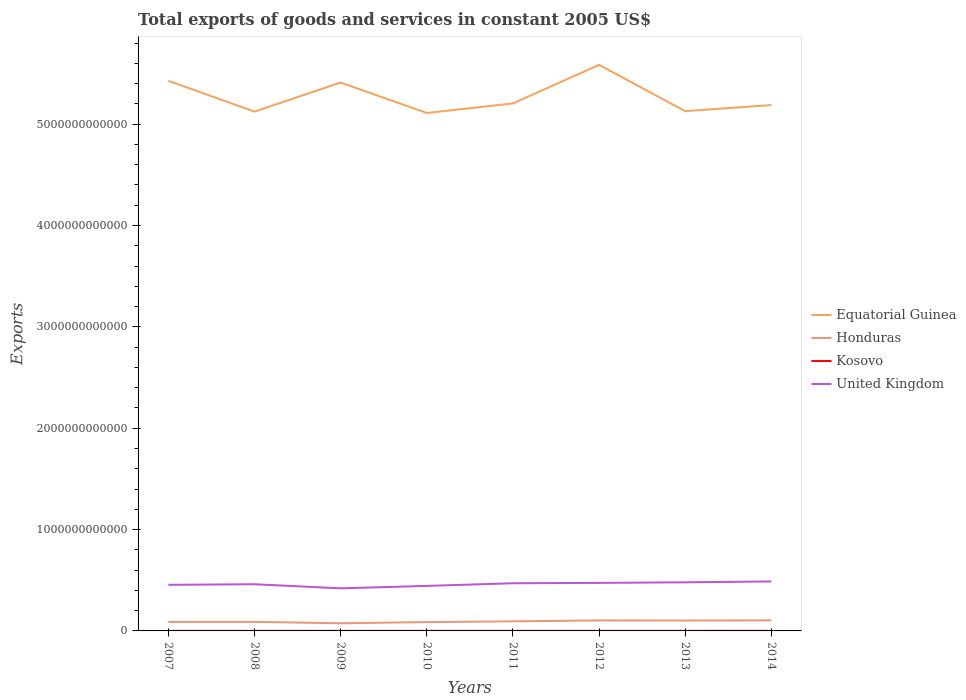Does the line corresponding to United Kingdom intersect with the line corresponding to Kosovo?
Your answer should be compact. No. Across all years, what is the maximum total exports of goods and services in United Kingdom?
Make the answer very short. 4.20e+11. What is the total total exports of goods and services in United Kingdom in the graph?
Provide a succinct answer. -5.37e+1. What is the difference between the highest and the second highest total exports of goods and services in Equatorial Guinea?
Your answer should be very brief. 4.75e+11. What is the difference between the highest and the lowest total exports of goods and services in Honduras?
Ensure brevity in your answer.  4. Is the total exports of goods and services in Kosovo strictly greater than the total exports of goods and services in Equatorial Guinea over the years?
Give a very brief answer. Yes. How many years are there in the graph?
Offer a terse response. 8. What is the difference between two consecutive major ticks on the Y-axis?
Your answer should be compact. 1.00e+12. Are the values on the major ticks of Y-axis written in scientific E-notation?
Keep it short and to the point. No. How many legend labels are there?
Your answer should be very brief. 4. How are the legend labels stacked?
Give a very brief answer. Vertical. What is the title of the graph?
Keep it short and to the point. Total exports of goods and services in constant 2005 US$. Does "Czech Republic" appear as one of the legend labels in the graph?
Give a very brief answer. No. What is the label or title of the Y-axis?
Your answer should be very brief. Exports. What is the Exports of Equatorial Guinea in 2007?
Give a very brief answer. 5.43e+12. What is the Exports in Honduras in 2007?
Make the answer very short. 8.89e+1. What is the Exports in Kosovo in 2007?
Offer a terse response. 6.08e+08. What is the Exports in United Kingdom in 2007?
Your answer should be compact. 4.55e+11. What is the Exports of Equatorial Guinea in 2008?
Your answer should be compact. 5.12e+12. What is the Exports of Honduras in 2008?
Offer a terse response. 8.96e+1. What is the Exports in Kosovo in 2008?
Your answer should be compact. 6.09e+08. What is the Exports in United Kingdom in 2008?
Give a very brief answer. 4.61e+11. What is the Exports in Equatorial Guinea in 2009?
Your response must be concise. 5.41e+12. What is the Exports in Honduras in 2009?
Keep it short and to the point. 7.54e+1. What is the Exports in Kosovo in 2009?
Your answer should be compact. 6.85e+08. What is the Exports of United Kingdom in 2009?
Your answer should be very brief. 4.20e+11. What is the Exports of Equatorial Guinea in 2010?
Make the answer very short. 5.11e+12. What is the Exports in Honduras in 2010?
Ensure brevity in your answer.  8.72e+1. What is the Exports of Kosovo in 2010?
Offer a very short reply. 7.70e+08. What is the Exports in United Kingdom in 2010?
Provide a short and direct response. 4.44e+11. What is the Exports in Equatorial Guinea in 2011?
Give a very brief answer. 5.20e+12. What is the Exports in Honduras in 2011?
Your answer should be compact. 9.45e+1. What is the Exports of Kosovo in 2011?
Your response must be concise. 8.00e+08. What is the Exports of United Kingdom in 2011?
Provide a succinct answer. 4.70e+11. What is the Exports in Equatorial Guinea in 2012?
Your answer should be very brief. 5.59e+12. What is the Exports of Honduras in 2012?
Give a very brief answer. 1.04e+11. What is the Exports in Kosovo in 2012?
Ensure brevity in your answer.  8.06e+08. What is the Exports in United Kingdom in 2012?
Offer a terse response. 4.74e+11. What is the Exports in Equatorial Guinea in 2013?
Your response must be concise. 5.13e+12. What is the Exports of Honduras in 2013?
Offer a very short reply. 1.02e+11. What is the Exports in Kosovo in 2013?
Provide a succinct answer. 8.24e+08. What is the Exports in United Kingdom in 2013?
Make the answer very short. 4.80e+11. What is the Exports of Equatorial Guinea in 2014?
Your answer should be compact. 5.19e+12. What is the Exports in Honduras in 2014?
Make the answer very short. 1.04e+11. What is the Exports in Kosovo in 2014?
Keep it short and to the point. 9.65e+08. What is the Exports in United Kingdom in 2014?
Your answer should be compact. 4.88e+11. Across all years, what is the maximum Exports of Equatorial Guinea?
Make the answer very short. 5.59e+12. Across all years, what is the maximum Exports in Honduras?
Your response must be concise. 1.04e+11. Across all years, what is the maximum Exports of Kosovo?
Offer a very short reply. 9.65e+08. Across all years, what is the maximum Exports in United Kingdom?
Your response must be concise. 4.88e+11. Across all years, what is the minimum Exports in Equatorial Guinea?
Ensure brevity in your answer.  5.11e+12. Across all years, what is the minimum Exports of Honduras?
Give a very brief answer. 7.54e+1. Across all years, what is the minimum Exports in Kosovo?
Your answer should be very brief. 6.08e+08. Across all years, what is the minimum Exports in United Kingdom?
Offer a very short reply. 4.20e+11. What is the total Exports of Equatorial Guinea in the graph?
Your answer should be very brief. 4.22e+13. What is the total Exports in Honduras in the graph?
Offer a very short reply. 7.46e+11. What is the total Exports of Kosovo in the graph?
Your answer should be very brief. 6.07e+09. What is the total Exports in United Kingdom in the graph?
Your answer should be compact. 3.69e+12. What is the difference between the Exports in Equatorial Guinea in 2007 and that in 2008?
Give a very brief answer. 3.04e+11. What is the difference between the Exports in Honduras in 2007 and that in 2008?
Provide a succinct answer. -7.64e+08. What is the difference between the Exports in Kosovo in 2007 and that in 2008?
Ensure brevity in your answer.  -5.00e+05. What is the difference between the Exports of United Kingdom in 2007 and that in 2008?
Provide a succinct answer. -5.89e+09. What is the difference between the Exports of Equatorial Guinea in 2007 and that in 2009?
Provide a succinct answer. 1.72e+1. What is the difference between the Exports of Honduras in 2007 and that in 2009?
Your answer should be compact. 1.35e+1. What is the difference between the Exports of Kosovo in 2007 and that in 2009?
Offer a very short reply. -7.64e+07. What is the difference between the Exports in United Kingdom in 2007 and that in 2009?
Your answer should be compact. 3.47e+1. What is the difference between the Exports in Equatorial Guinea in 2007 and that in 2010?
Offer a terse response. 3.18e+11. What is the difference between the Exports of Honduras in 2007 and that in 2010?
Your answer should be compact. 1.66e+09. What is the difference between the Exports in Kosovo in 2007 and that in 2010?
Offer a very short reply. -1.62e+08. What is the difference between the Exports of United Kingdom in 2007 and that in 2010?
Ensure brevity in your answer.  1.05e+1. What is the difference between the Exports in Equatorial Guinea in 2007 and that in 2011?
Provide a short and direct response. 2.23e+11. What is the difference between the Exports of Honduras in 2007 and that in 2011?
Your answer should be compact. -5.63e+09. What is the difference between the Exports of Kosovo in 2007 and that in 2011?
Ensure brevity in your answer.  -1.92e+08. What is the difference between the Exports in United Kingdom in 2007 and that in 2011?
Keep it short and to the point. -1.55e+1. What is the difference between the Exports of Equatorial Guinea in 2007 and that in 2012?
Keep it short and to the point. -1.57e+11. What is the difference between the Exports in Honduras in 2007 and that in 2012?
Your answer should be very brief. -1.49e+1. What is the difference between the Exports in Kosovo in 2007 and that in 2012?
Offer a terse response. -1.97e+08. What is the difference between the Exports in United Kingdom in 2007 and that in 2012?
Ensure brevity in your answer.  -1.90e+1. What is the difference between the Exports in Equatorial Guinea in 2007 and that in 2013?
Your answer should be compact. 2.99e+11. What is the difference between the Exports in Honduras in 2007 and that in 2013?
Provide a succinct answer. -1.36e+1. What is the difference between the Exports of Kosovo in 2007 and that in 2013?
Your answer should be very brief. -2.16e+08. What is the difference between the Exports of United Kingdom in 2007 and that in 2013?
Keep it short and to the point. -2.48e+1. What is the difference between the Exports in Equatorial Guinea in 2007 and that in 2014?
Give a very brief answer. 2.39e+11. What is the difference between the Exports in Honduras in 2007 and that in 2014?
Offer a very short reply. -1.52e+1. What is the difference between the Exports of Kosovo in 2007 and that in 2014?
Offer a very short reply. -3.57e+08. What is the difference between the Exports in United Kingdom in 2007 and that in 2014?
Offer a very short reply. -3.35e+1. What is the difference between the Exports in Equatorial Guinea in 2008 and that in 2009?
Offer a very short reply. -2.87e+11. What is the difference between the Exports of Honduras in 2008 and that in 2009?
Your answer should be compact. 1.42e+1. What is the difference between the Exports of Kosovo in 2008 and that in 2009?
Offer a very short reply. -7.59e+07. What is the difference between the Exports of United Kingdom in 2008 and that in 2009?
Ensure brevity in your answer.  4.05e+1. What is the difference between the Exports in Equatorial Guinea in 2008 and that in 2010?
Your answer should be compact. 1.39e+1. What is the difference between the Exports in Honduras in 2008 and that in 2010?
Provide a short and direct response. 2.42e+09. What is the difference between the Exports in Kosovo in 2008 and that in 2010?
Keep it short and to the point. -1.62e+08. What is the difference between the Exports in United Kingdom in 2008 and that in 2010?
Your answer should be compact. 1.63e+1. What is the difference between the Exports of Equatorial Guinea in 2008 and that in 2011?
Keep it short and to the point. -8.05e+1. What is the difference between the Exports in Honduras in 2008 and that in 2011?
Your answer should be compact. -4.87e+09. What is the difference between the Exports of Kosovo in 2008 and that in 2011?
Ensure brevity in your answer.  -1.91e+08. What is the difference between the Exports in United Kingdom in 2008 and that in 2011?
Your answer should be compact. -9.64e+09. What is the difference between the Exports in Equatorial Guinea in 2008 and that in 2012?
Ensure brevity in your answer.  -4.61e+11. What is the difference between the Exports of Honduras in 2008 and that in 2012?
Provide a succinct answer. -1.42e+1. What is the difference between the Exports of Kosovo in 2008 and that in 2012?
Give a very brief answer. -1.97e+08. What is the difference between the Exports of United Kingdom in 2008 and that in 2012?
Make the answer very short. -1.32e+1. What is the difference between the Exports of Equatorial Guinea in 2008 and that in 2013?
Ensure brevity in your answer.  -4.32e+09. What is the difference between the Exports in Honduras in 2008 and that in 2013?
Provide a succinct answer. -1.28e+1. What is the difference between the Exports in Kosovo in 2008 and that in 2013?
Provide a short and direct response. -2.15e+08. What is the difference between the Exports in United Kingdom in 2008 and that in 2013?
Your answer should be compact. -1.89e+1. What is the difference between the Exports of Equatorial Guinea in 2008 and that in 2014?
Offer a terse response. -6.45e+1. What is the difference between the Exports of Honduras in 2008 and that in 2014?
Keep it short and to the point. -1.45e+1. What is the difference between the Exports in Kosovo in 2008 and that in 2014?
Give a very brief answer. -3.56e+08. What is the difference between the Exports in United Kingdom in 2008 and that in 2014?
Your answer should be compact. -2.76e+1. What is the difference between the Exports in Equatorial Guinea in 2009 and that in 2010?
Your response must be concise. 3.01e+11. What is the difference between the Exports in Honduras in 2009 and that in 2010?
Make the answer very short. -1.18e+1. What is the difference between the Exports of Kosovo in 2009 and that in 2010?
Offer a terse response. -8.56e+07. What is the difference between the Exports of United Kingdom in 2009 and that in 2010?
Your answer should be compact. -2.42e+1. What is the difference between the Exports in Equatorial Guinea in 2009 and that in 2011?
Provide a succinct answer. 2.06e+11. What is the difference between the Exports of Honduras in 2009 and that in 2011?
Keep it short and to the point. -1.91e+1. What is the difference between the Exports of Kosovo in 2009 and that in 2011?
Offer a terse response. -1.15e+08. What is the difference between the Exports in United Kingdom in 2009 and that in 2011?
Make the answer very short. -5.02e+1. What is the difference between the Exports in Equatorial Guinea in 2009 and that in 2012?
Give a very brief answer. -1.74e+11. What is the difference between the Exports in Honduras in 2009 and that in 2012?
Keep it short and to the point. -2.84e+1. What is the difference between the Exports in Kosovo in 2009 and that in 2012?
Your answer should be compact. -1.21e+08. What is the difference between the Exports in United Kingdom in 2009 and that in 2012?
Your answer should be very brief. -5.37e+1. What is the difference between the Exports of Equatorial Guinea in 2009 and that in 2013?
Keep it short and to the point. 2.82e+11. What is the difference between the Exports in Honduras in 2009 and that in 2013?
Give a very brief answer. -2.71e+1. What is the difference between the Exports of Kosovo in 2009 and that in 2013?
Give a very brief answer. -1.39e+08. What is the difference between the Exports in United Kingdom in 2009 and that in 2013?
Give a very brief answer. -5.94e+1. What is the difference between the Exports in Equatorial Guinea in 2009 and that in 2014?
Keep it short and to the point. 2.22e+11. What is the difference between the Exports of Honduras in 2009 and that in 2014?
Ensure brevity in your answer.  -2.87e+1. What is the difference between the Exports of Kosovo in 2009 and that in 2014?
Your response must be concise. -2.80e+08. What is the difference between the Exports of United Kingdom in 2009 and that in 2014?
Provide a succinct answer. -6.81e+1. What is the difference between the Exports of Equatorial Guinea in 2010 and that in 2011?
Offer a terse response. -9.44e+1. What is the difference between the Exports in Honduras in 2010 and that in 2011?
Your answer should be compact. -7.29e+09. What is the difference between the Exports of Kosovo in 2010 and that in 2011?
Provide a succinct answer. -2.96e+07. What is the difference between the Exports in United Kingdom in 2010 and that in 2011?
Keep it short and to the point. -2.60e+1. What is the difference between the Exports in Equatorial Guinea in 2010 and that in 2012?
Provide a short and direct response. -4.75e+11. What is the difference between the Exports of Honduras in 2010 and that in 2012?
Provide a succinct answer. -1.66e+1. What is the difference between the Exports in Kosovo in 2010 and that in 2012?
Ensure brevity in your answer.  -3.52e+07. What is the difference between the Exports in United Kingdom in 2010 and that in 2012?
Give a very brief answer. -2.95e+1. What is the difference between the Exports in Equatorial Guinea in 2010 and that in 2013?
Provide a short and direct response. -1.83e+1. What is the difference between the Exports of Honduras in 2010 and that in 2013?
Provide a succinct answer. -1.53e+1. What is the difference between the Exports in Kosovo in 2010 and that in 2013?
Make the answer very short. -5.38e+07. What is the difference between the Exports in United Kingdom in 2010 and that in 2013?
Keep it short and to the point. -3.52e+1. What is the difference between the Exports of Equatorial Guinea in 2010 and that in 2014?
Your answer should be very brief. -7.84e+1. What is the difference between the Exports of Honduras in 2010 and that in 2014?
Provide a succinct answer. -1.69e+1. What is the difference between the Exports in Kosovo in 2010 and that in 2014?
Provide a succinct answer. -1.95e+08. What is the difference between the Exports of United Kingdom in 2010 and that in 2014?
Keep it short and to the point. -4.39e+1. What is the difference between the Exports of Equatorial Guinea in 2011 and that in 2012?
Make the answer very short. -3.80e+11. What is the difference between the Exports in Honduras in 2011 and that in 2012?
Give a very brief answer. -9.31e+09. What is the difference between the Exports of Kosovo in 2011 and that in 2012?
Give a very brief answer. -5.60e+06. What is the difference between the Exports in United Kingdom in 2011 and that in 2012?
Offer a terse response. -3.51e+09. What is the difference between the Exports in Equatorial Guinea in 2011 and that in 2013?
Offer a very short reply. 7.62e+1. What is the difference between the Exports in Honduras in 2011 and that in 2013?
Offer a very short reply. -7.98e+09. What is the difference between the Exports of Kosovo in 2011 and that in 2013?
Offer a terse response. -2.42e+07. What is the difference between the Exports in United Kingdom in 2011 and that in 2013?
Offer a terse response. -9.24e+09. What is the difference between the Exports in Equatorial Guinea in 2011 and that in 2014?
Offer a terse response. 1.60e+1. What is the difference between the Exports of Honduras in 2011 and that in 2014?
Keep it short and to the point. -9.58e+09. What is the difference between the Exports in Kosovo in 2011 and that in 2014?
Keep it short and to the point. -1.65e+08. What is the difference between the Exports in United Kingdom in 2011 and that in 2014?
Provide a short and direct response. -1.79e+1. What is the difference between the Exports in Equatorial Guinea in 2012 and that in 2013?
Your response must be concise. 4.57e+11. What is the difference between the Exports of Honduras in 2012 and that in 2013?
Give a very brief answer. 1.33e+09. What is the difference between the Exports in Kosovo in 2012 and that in 2013?
Keep it short and to the point. -1.86e+07. What is the difference between the Exports of United Kingdom in 2012 and that in 2013?
Your answer should be compact. -5.73e+09. What is the difference between the Exports of Equatorial Guinea in 2012 and that in 2014?
Provide a short and direct response. 3.96e+11. What is the difference between the Exports of Honduras in 2012 and that in 2014?
Keep it short and to the point. -2.79e+08. What is the difference between the Exports of Kosovo in 2012 and that in 2014?
Ensure brevity in your answer.  -1.59e+08. What is the difference between the Exports of United Kingdom in 2012 and that in 2014?
Ensure brevity in your answer.  -1.44e+1. What is the difference between the Exports in Equatorial Guinea in 2013 and that in 2014?
Your response must be concise. -6.02e+1. What is the difference between the Exports in Honduras in 2013 and that in 2014?
Keep it short and to the point. -1.61e+09. What is the difference between the Exports of Kosovo in 2013 and that in 2014?
Provide a succinct answer. -1.41e+08. What is the difference between the Exports in United Kingdom in 2013 and that in 2014?
Offer a terse response. -8.71e+09. What is the difference between the Exports of Equatorial Guinea in 2007 and the Exports of Honduras in 2008?
Offer a very short reply. 5.34e+12. What is the difference between the Exports in Equatorial Guinea in 2007 and the Exports in Kosovo in 2008?
Keep it short and to the point. 5.43e+12. What is the difference between the Exports of Equatorial Guinea in 2007 and the Exports of United Kingdom in 2008?
Offer a very short reply. 4.97e+12. What is the difference between the Exports of Honduras in 2007 and the Exports of Kosovo in 2008?
Your answer should be very brief. 8.82e+1. What is the difference between the Exports of Honduras in 2007 and the Exports of United Kingdom in 2008?
Ensure brevity in your answer.  -3.72e+11. What is the difference between the Exports of Kosovo in 2007 and the Exports of United Kingdom in 2008?
Give a very brief answer. -4.60e+11. What is the difference between the Exports in Equatorial Guinea in 2007 and the Exports in Honduras in 2009?
Your response must be concise. 5.35e+12. What is the difference between the Exports of Equatorial Guinea in 2007 and the Exports of Kosovo in 2009?
Your response must be concise. 5.43e+12. What is the difference between the Exports in Equatorial Guinea in 2007 and the Exports in United Kingdom in 2009?
Your answer should be compact. 5.01e+12. What is the difference between the Exports of Honduras in 2007 and the Exports of Kosovo in 2009?
Your answer should be compact. 8.82e+1. What is the difference between the Exports of Honduras in 2007 and the Exports of United Kingdom in 2009?
Offer a terse response. -3.31e+11. What is the difference between the Exports in Kosovo in 2007 and the Exports in United Kingdom in 2009?
Your response must be concise. -4.20e+11. What is the difference between the Exports in Equatorial Guinea in 2007 and the Exports in Honduras in 2010?
Give a very brief answer. 5.34e+12. What is the difference between the Exports in Equatorial Guinea in 2007 and the Exports in Kosovo in 2010?
Give a very brief answer. 5.43e+12. What is the difference between the Exports in Equatorial Guinea in 2007 and the Exports in United Kingdom in 2010?
Keep it short and to the point. 4.98e+12. What is the difference between the Exports in Honduras in 2007 and the Exports in Kosovo in 2010?
Your answer should be very brief. 8.81e+1. What is the difference between the Exports in Honduras in 2007 and the Exports in United Kingdom in 2010?
Ensure brevity in your answer.  -3.56e+11. What is the difference between the Exports of Kosovo in 2007 and the Exports of United Kingdom in 2010?
Ensure brevity in your answer.  -4.44e+11. What is the difference between the Exports of Equatorial Guinea in 2007 and the Exports of Honduras in 2011?
Give a very brief answer. 5.33e+12. What is the difference between the Exports of Equatorial Guinea in 2007 and the Exports of Kosovo in 2011?
Ensure brevity in your answer.  5.43e+12. What is the difference between the Exports in Equatorial Guinea in 2007 and the Exports in United Kingdom in 2011?
Your response must be concise. 4.96e+12. What is the difference between the Exports of Honduras in 2007 and the Exports of Kosovo in 2011?
Your response must be concise. 8.81e+1. What is the difference between the Exports of Honduras in 2007 and the Exports of United Kingdom in 2011?
Your answer should be compact. -3.81e+11. What is the difference between the Exports in Kosovo in 2007 and the Exports in United Kingdom in 2011?
Your answer should be very brief. -4.70e+11. What is the difference between the Exports in Equatorial Guinea in 2007 and the Exports in Honduras in 2012?
Provide a succinct answer. 5.32e+12. What is the difference between the Exports of Equatorial Guinea in 2007 and the Exports of Kosovo in 2012?
Offer a very short reply. 5.43e+12. What is the difference between the Exports of Equatorial Guinea in 2007 and the Exports of United Kingdom in 2012?
Your answer should be very brief. 4.95e+12. What is the difference between the Exports of Honduras in 2007 and the Exports of Kosovo in 2012?
Ensure brevity in your answer.  8.80e+1. What is the difference between the Exports of Honduras in 2007 and the Exports of United Kingdom in 2012?
Provide a short and direct response. -3.85e+11. What is the difference between the Exports of Kosovo in 2007 and the Exports of United Kingdom in 2012?
Provide a short and direct response. -4.73e+11. What is the difference between the Exports of Equatorial Guinea in 2007 and the Exports of Honduras in 2013?
Your answer should be compact. 5.33e+12. What is the difference between the Exports in Equatorial Guinea in 2007 and the Exports in Kosovo in 2013?
Your response must be concise. 5.43e+12. What is the difference between the Exports in Equatorial Guinea in 2007 and the Exports in United Kingdom in 2013?
Offer a terse response. 4.95e+12. What is the difference between the Exports of Honduras in 2007 and the Exports of Kosovo in 2013?
Your answer should be very brief. 8.80e+1. What is the difference between the Exports in Honduras in 2007 and the Exports in United Kingdom in 2013?
Ensure brevity in your answer.  -3.91e+11. What is the difference between the Exports of Kosovo in 2007 and the Exports of United Kingdom in 2013?
Keep it short and to the point. -4.79e+11. What is the difference between the Exports in Equatorial Guinea in 2007 and the Exports in Honduras in 2014?
Your response must be concise. 5.32e+12. What is the difference between the Exports in Equatorial Guinea in 2007 and the Exports in Kosovo in 2014?
Provide a short and direct response. 5.43e+12. What is the difference between the Exports in Equatorial Guinea in 2007 and the Exports in United Kingdom in 2014?
Give a very brief answer. 4.94e+12. What is the difference between the Exports of Honduras in 2007 and the Exports of Kosovo in 2014?
Provide a succinct answer. 8.79e+1. What is the difference between the Exports of Honduras in 2007 and the Exports of United Kingdom in 2014?
Provide a succinct answer. -3.99e+11. What is the difference between the Exports in Kosovo in 2007 and the Exports in United Kingdom in 2014?
Offer a very short reply. -4.88e+11. What is the difference between the Exports in Equatorial Guinea in 2008 and the Exports in Honduras in 2009?
Make the answer very short. 5.05e+12. What is the difference between the Exports of Equatorial Guinea in 2008 and the Exports of Kosovo in 2009?
Provide a succinct answer. 5.12e+12. What is the difference between the Exports of Equatorial Guinea in 2008 and the Exports of United Kingdom in 2009?
Make the answer very short. 4.70e+12. What is the difference between the Exports in Honduras in 2008 and the Exports in Kosovo in 2009?
Offer a very short reply. 8.89e+1. What is the difference between the Exports of Honduras in 2008 and the Exports of United Kingdom in 2009?
Offer a very short reply. -3.31e+11. What is the difference between the Exports in Kosovo in 2008 and the Exports in United Kingdom in 2009?
Make the answer very short. -4.20e+11. What is the difference between the Exports in Equatorial Guinea in 2008 and the Exports in Honduras in 2010?
Your response must be concise. 5.04e+12. What is the difference between the Exports of Equatorial Guinea in 2008 and the Exports of Kosovo in 2010?
Make the answer very short. 5.12e+12. What is the difference between the Exports of Equatorial Guinea in 2008 and the Exports of United Kingdom in 2010?
Make the answer very short. 4.68e+12. What is the difference between the Exports of Honduras in 2008 and the Exports of Kosovo in 2010?
Offer a terse response. 8.88e+1. What is the difference between the Exports of Honduras in 2008 and the Exports of United Kingdom in 2010?
Your response must be concise. -3.55e+11. What is the difference between the Exports of Kosovo in 2008 and the Exports of United Kingdom in 2010?
Offer a terse response. -4.44e+11. What is the difference between the Exports in Equatorial Guinea in 2008 and the Exports in Honduras in 2011?
Ensure brevity in your answer.  5.03e+12. What is the difference between the Exports in Equatorial Guinea in 2008 and the Exports in Kosovo in 2011?
Provide a succinct answer. 5.12e+12. What is the difference between the Exports in Equatorial Guinea in 2008 and the Exports in United Kingdom in 2011?
Your answer should be compact. 4.65e+12. What is the difference between the Exports of Honduras in 2008 and the Exports of Kosovo in 2011?
Provide a short and direct response. 8.88e+1. What is the difference between the Exports of Honduras in 2008 and the Exports of United Kingdom in 2011?
Offer a very short reply. -3.81e+11. What is the difference between the Exports in Kosovo in 2008 and the Exports in United Kingdom in 2011?
Keep it short and to the point. -4.70e+11. What is the difference between the Exports of Equatorial Guinea in 2008 and the Exports of Honduras in 2012?
Offer a terse response. 5.02e+12. What is the difference between the Exports in Equatorial Guinea in 2008 and the Exports in Kosovo in 2012?
Keep it short and to the point. 5.12e+12. What is the difference between the Exports of Equatorial Guinea in 2008 and the Exports of United Kingdom in 2012?
Your answer should be compact. 4.65e+12. What is the difference between the Exports in Honduras in 2008 and the Exports in Kosovo in 2012?
Ensure brevity in your answer.  8.88e+1. What is the difference between the Exports of Honduras in 2008 and the Exports of United Kingdom in 2012?
Provide a succinct answer. -3.84e+11. What is the difference between the Exports in Kosovo in 2008 and the Exports in United Kingdom in 2012?
Your response must be concise. -4.73e+11. What is the difference between the Exports of Equatorial Guinea in 2008 and the Exports of Honduras in 2013?
Ensure brevity in your answer.  5.02e+12. What is the difference between the Exports in Equatorial Guinea in 2008 and the Exports in Kosovo in 2013?
Your response must be concise. 5.12e+12. What is the difference between the Exports in Equatorial Guinea in 2008 and the Exports in United Kingdom in 2013?
Ensure brevity in your answer.  4.64e+12. What is the difference between the Exports of Honduras in 2008 and the Exports of Kosovo in 2013?
Your response must be concise. 8.88e+1. What is the difference between the Exports of Honduras in 2008 and the Exports of United Kingdom in 2013?
Your answer should be very brief. -3.90e+11. What is the difference between the Exports in Kosovo in 2008 and the Exports in United Kingdom in 2013?
Give a very brief answer. -4.79e+11. What is the difference between the Exports in Equatorial Guinea in 2008 and the Exports in Honduras in 2014?
Your answer should be compact. 5.02e+12. What is the difference between the Exports of Equatorial Guinea in 2008 and the Exports of Kosovo in 2014?
Offer a terse response. 5.12e+12. What is the difference between the Exports in Equatorial Guinea in 2008 and the Exports in United Kingdom in 2014?
Offer a very short reply. 4.64e+12. What is the difference between the Exports in Honduras in 2008 and the Exports in Kosovo in 2014?
Your answer should be very brief. 8.87e+1. What is the difference between the Exports in Honduras in 2008 and the Exports in United Kingdom in 2014?
Keep it short and to the point. -3.99e+11. What is the difference between the Exports in Kosovo in 2008 and the Exports in United Kingdom in 2014?
Provide a short and direct response. -4.88e+11. What is the difference between the Exports in Equatorial Guinea in 2009 and the Exports in Honduras in 2010?
Your answer should be very brief. 5.32e+12. What is the difference between the Exports in Equatorial Guinea in 2009 and the Exports in Kosovo in 2010?
Keep it short and to the point. 5.41e+12. What is the difference between the Exports in Equatorial Guinea in 2009 and the Exports in United Kingdom in 2010?
Give a very brief answer. 4.97e+12. What is the difference between the Exports in Honduras in 2009 and the Exports in Kosovo in 2010?
Provide a succinct answer. 7.46e+1. What is the difference between the Exports of Honduras in 2009 and the Exports of United Kingdom in 2010?
Provide a succinct answer. -3.69e+11. What is the difference between the Exports of Kosovo in 2009 and the Exports of United Kingdom in 2010?
Keep it short and to the point. -4.44e+11. What is the difference between the Exports of Equatorial Guinea in 2009 and the Exports of Honduras in 2011?
Provide a succinct answer. 5.32e+12. What is the difference between the Exports of Equatorial Guinea in 2009 and the Exports of Kosovo in 2011?
Offer a terse response. 5.41e+12. What is the difference between the Exports of Equatorial Guinea in 2009 and the Exports of United Kingdom in 2011?
Your answer should be compact. 4.94e+12. What is the difference between the Exports in Honduras in 2009 and the Exports in Kosovo in 2011?
Give a very brief answer. 7.46e+1. What is the difference between the Exports in Honduras in 2009 and the Exports in United Kingdom in 2011?
Offer a terse response. -3.95e+11. What is the difference between the Exports in Kosovo in 2009 and the Exports in United Kingdom in 2011?
Make the answer very short. -4.70e+11. What is the difference between the Exports in Equatorial Guinea in 2009 and the Exports in Honduras in 2012?
Give a very brief answer. 5.31e+12. What is the difference between the Exports in Equatorial Guinea in 2009 and the Exports in Kosovo in 2012?
Ensure brevity in your answer.  5.41e+12. What is the difference between the Exports in Equatorial Guinea in 2009 and the Exports in United Kingdom in 2012?
Keep it short and to the point. 4.94e+12. What is the difference between the Exports of Honduras in 2009 and the Exports of Kosovo in 2012?
Your answer should be compact. 7.46e+1. What is the difference between the Exports in Honduras in 2009 and the Exports in United Kingdom in 2012?
Offer a terse response. -3.98e+11. What is the difference between the Exports in Kosovo in 2009 and the Exports in United Kingdom in 2012?
Give a very brief answer. -4.73e+11. What is the difference between the Exports of Equatorial Guinea in 2009 and the Exports of Honduras in 2013?
Make the answer very short. 5.31e+12. What is the difference between the Exports in Equatorial Guinea in 2009 and the Exports in Kosovo in 2013?
Offer a very short reply. 5.41e+12. What is the difference between the Exports of Equatorial Guinea in 2009 and the Exports of United Kingdom in 2013?
Provide a short and direct response. 4.93e+12. What is the difference between the Exports in Honduras in 2009 and the Exports in Kosovo in 2013?
Offer a terse response. 7.45e+1. What is the difference between the Exports in Honduras in 2009 and the Exports in United Kingdom in 2013?
Provide a succinct answer. -4.04e+11. What is the difference between the Exports in Kosovo in 2009 and the Exports in United Kingdom in 2013?
Provide a succinct answer. -4.79e+11. What is the difference between the Exports in Equatorial Guinea in 2009 and the Exports in Honduras in 2014?
Your answer should be compact. 5.31e+12. What is the difference between the Exports in Equatorial Guinea in 2009 and the Exports in Kosovo in 2014?
Offer a terse response. 5.41e+12. What is the difference between the Exports in Equatorial Guinea in 2009 and the Exports in United Kingdom in 2014?
Your response must be concise. 4.92e+12. What is the difference between the Exports of Honduras in 2009 and the Exports of Kosovo in 2014?
Offer a very short reply. 7.44e+1. What is the difference between the Exports in Honduras in 2009 and the Exports in United Kingdom in 2014?
Provide a succinct answer. -4.13e+11. What is the difference between the Exports in Kosovo in 2009 and the Exports in United Kingdom in 2014?
Ensure brevity in your answer.  -4.88e+11. What is the difference between the Exports in Equatorial Guinea in 2010 and the Exports in Honduras in 2011?
Your answer should be very brief. 5.02e+12. What is the difference between the Exports in Equatorial Guinea in 2010 and the Exports in Kosovo in 2011?
Provide a short and direct response. 5.11e+12. What is the difference between the Exports in Equatorial Guinea in 2010 and the Exports in United Kingdom in 2011?
Your response must be concise. 4.64e+12. What is the difference between the Exports of Honduras in 2010 and the Exports of Kosovo in 2011?
Provide a short and direct response. 8.64e+1. What is the difference between the Exports of Honduras in 2010 and the Exports of United Kingdom in 2011?
Offer a terse response. -3.83e+11. What is the difference between the Exports of Kosovo in 2010 and the Exports of United Kingdom in 2011?
Provide a succinct answer. -4.70e+11. What is the difference between the Exports of Equatorial Guinea in 2010 and the Exports of Honduras in 2012?
Keep it short and to the point. 5.01e+12. What is the difference between the Exports in Equatorial Guinea in 2010 and the Exports in Kosovo in 2012?
Your answer should be very brief. 5.11e+12. What is the difference between the Exports of Equatorial Guinea in 2010 and the Exports of United Kingdom in 2012?
Provide a short and direct response. 4.64e+12. What is the difference between the Exports in Honduras in 2010 and the Exports in Kosovo in 2012?
Your response must be concise. 8.64e+1. What is the difference between the Exports of Honduras in 2010 and the Exports of United Kingdom in 2012?
Offer a terse response. -3.87e+11. What is the difference between the Exports of Kosovo in 2010 and the Exports of United Kingdom in 2012?
Offer a terse response. -4.73e+11. What is the difference between the Exports of Equatorial Guinea in 2010 and the Exports of Honduras in 2013?
Your answer should be compact. 5.01e+12. What is the difference between the Exports of Equatorial Guinea in 2010 and the Exports of Kosovo in 2013?
Give a very brief answer. 5.11e+12. What is the difference between the Exports in Equatorial Guinea in 2010 and the Exports in United Kingdom in 2013?
Give a very brief answer. 4.63e+12. What is the difference between the Exports of Honduras in 2010 and the Exports of Kosovo in 2013?
Provide a succinct answer. 8.64e+1. What is the difference between the Exports in Honduras in 2010 and the Exports in United Kingdom in 2013?
Your answer should be compact. -3.92e+11. What is the difference between the Exports of Kosovo in 2010 and the Exports of United Kingdom in 2013?
Your answer should be very brief. -4.79e+11. What is the difference between the Exports of Equatorial Guinea in 2010 and the Exports of Honduras in 2014?
Your answer should be compact. 5.01e+12. What is the difference between the Exports in Equatorial Guinea in 2010 and the Exports in Kosovo in 2014?
Keep it short and to the point. 5.11e+12. What is the difference between the Exports of Equatorial Guinea in 2010 and the Exports of United Kingdom in 2014?
Keep it short and to the point. 4.62e+12. What is the difference between the Exports of Honduras in 2010 and the Exports of Kosovo in 2014?
Offer a terse response. 8.62e+1. What is the difference between the Exports of Honduras in 2010 and the Exports of United Kingdom in 2014?
Make the answer very short. -4.01e+11. What is the difference between the Exports in Kosovo in 2010 and the Exports in United Kingdom in 2014?
Your answer should be very brief. -4.88e+11. What is the difference between the Exports in Equatorial Guinea in 2011 and the Exports in Honduras in 2012?
Provide a succinct answer. 5.10e+12. What is the difference between the Exports in Equatorial Guinea in 2011 and the Exports in Kosovo in 2012?
Offer a terse response. 5.20e+12. What is the difference between the Exports in Equatorial Guinea in 2011 and the Exports in United Kingdom in 2012?
Your answer should be compact. 4.73e+12. What is the difference between the Exports of Honduras in 2011 and the Exports of Kosovo in 2012?
Ensure brevity in your answer.  9.37e+1. What is the difference between the Exports of Honduras in 2011 and the Exports of United Kingdom in 2012?
Provide a succinct answer. -3.79e+11. What is the difference between the Exports in Kosovo in 2011 and the Exports in United Kingdom in 2012?
Make the answer very short. -4.73e+11. What is the difference between the Exports of Equatorial Guinea in 2011 and the Exports of Honduras in 2013?
Give a very brief answer. 5.10e+12. What is the difference between the Exports in Equatorial Guinea in 2011 and the Exports in Kosovo in 2013?
Give a very brief answer. 5.20e+12. What is the difference between the Exports of Equatorial Guinea in 2011 and the Exports of United Kingdom in 2013?
Give a very brief answer. 4.72e+12. What is the difference between the Exports in Honduras in 2011 and the Exports in Kosovo in 2013?
Your response must be concise. 9.37e+1. What is the difference between the Exports in Honduras in 2011 and the Exports in United Kingdom in 2013?
Provide a succinct answer. -3.85e+11. What is the difference between the Exports of Kosovo in 2011 and the Exports of United Kingdom in 2013?
Your answer should be compact. -4.79e+11. What is the difference between the Exports of Equatorial Guinea in 2011 and the Exports of Honduras in 2014?
Ensure brevity in your answer.  5.10e+12. What is the difference between the Exports of Equatorial Guinea in 2011 and the Exports of Kosovo in 2014?
Give a very brief answer. 5.20e+12. What is the difference between the Exports in Equatorial Guinea in 2011 and the Exports in United Kingdom in 2014?
Offer a terse response. 4.72e+12. What is the difference between the Exports in Honduras in 2011 and the Exports in Kosovo in 2014?
Ensure brevity in your answer.  9.35e+1. What is the difference between the Exports of Honduras in 2011 and the Exports of United Kingdom in 2014?
Your answer should be very brief. -3.94e+11. What is the difference between the Exports in Kosovo in 2011 and the Exports in United Kingdom in 2014?
Give a very brief answer. -4.87e+11. What is the difference between the Exports of Equatorial Guinea in 2012 and the Exports of Honduras in 2013?
Your answer should be very brief. 5.48e+12. What is the difference between the Exports of Equatorial Guinea in 2012 and the Exports of Kosovo in 2013?
Provide a succinct answer. 5.58e+12. What is the difference between the Exports in Equatorial Guinea in 2012 and the Exports in United Kingdom in 2013?
Make the answer very short. 5.11e+12. What is the difference between the Exports in Honduras in 2012 and the Exports in Kosovo in 2013?
Provide a short and direct response. 1.03e+11. What is the difference between the Exports of Honduras in 2012 and the Exports of United Kingdom in 2013?
Keep it short and to the point. -3.76e+11. What is the difference between the Exports in Kosovo in 2012 and the Exports in United Kingdom in 2013?
Give a very brief answer. -4.79e+11. What is the difference between the Exports in Equatorial Guinea in 2012 and the Exports in Honduras in 2014?
Make the answer very short. 5.48e+12. What is the difference between the Exports of Equatorial Guinea in 2012 and the Exports of Kosovo in 2014?
Make the answer very short. 5.58e+12. What is the difference between the Exports of Equatorial Guinea in 2012 and the Exports of United Kingdom in 2014?
Keep it short and to the point. 5.10e+12. What is the difference between the Exports of Honduras in 2012 and the Exports of Kosovo in 2014?
Keep it short and to the point. 1.03e+11. What is the difference between the Exports in Honduras in 2012 and the Exports in United Kingdom in 2014?
Keep it short and to the point. -3.85e+11. What is the difference between the Exports in Kosovo in 2012 and the Exports in United Kingdom in 2014?
Keep it short and to the point. -4.87e+11. What is the difference between the Exports of Equatorial Guinea in 2013 and the Exports of Honduras in 2014?
Offer a terse response. 5.02e+12. What is the difference between the Exports of Equatorial Guinea in 2013 and the Exports of Kosovo in 2014?
Your response must be concise. 5.13e+12. What is the difference between the Exports in Equatorial Guinea in 2013 and the Exports in United Kingdom in 2014?
Keep it short and to the point. 4.64e+12. What is the difference between the Exports of Honduras in 2013 and the Exports of Kosovo in 2014?
Provide a succinct answer. 1.01e+11. What is the difference between the Exports of Honduras in 2013 and the Exports of United Kingdom in 2014?
Ensure brevity in your answer.  -3.86e+11. What is the difference between the Exports in Kosovo in 2013 and the Exports in United Kingdom in 2014?
Keep it short and to the point. -4.87e+11. What is the average Exports in Equatorial Guinea per year?
Your answer should be very brief. 5.27e+12. What is the average Exports of Honduras per year?
Offer a very short reply. 9.32e+1. What is the average Exports in Kosovo per year?
Offer a terse response. 7.58e+08. What is the average Exports in United Kingdom per year?
Ensure brevity in your answer.  4.62e+11. In the year 2007, what is the difference between the Exports of Equatorial Guinea and Exports of Honduras?
Provide a short and direct response. 5.34e+12. In the year 2007, what is the difference between the Exports of Equatorial Guinea and Exports of Kosovo?
Offer a terse response. 5.43e+12. In the year 2007, what is the difference between the Exports of Equatorial Guinea and Exports of United Kingdom?
Make the answer very short. 4.97e+12. In the year 2007, what is the difference between the Exports of Honduras and Exports of Kosovo?
Your answer should be compact. 8.82e+1. In the year 2007, what is the difference between the Exports of Honduras and Exports of United Kingdom?
Give a very brief answer. -3.66e+11. In the year 2007, what is the difference between the Exports in Kosovo and Exports in United Kingdom?
Make the answer very short. -4.54e+11. In the year 2008, what is the difference between the Exports in Equatorial Guinea and Exports in Honduras?
Offer a very short reply. 5.03e+12. In the year 2008, what is the difference between the Exports of Equatorial Guinea and Exports of Kosovo?
Your answer should be compact. 5.12e+12. In the year 2008, what is the difference between the Exports in Equatorial Guinea and Exports in United Kingdom?
Offer a very short reply. 4.66e+12. In the year 2008, what is the difference between the Exports of Honduras and Exports of Kosovo?
Offer a terse response. 8.90e+1. In the year 2008, what is the difference between the Exports of Honduras and Exports of United Kingdom?
Make the answer very short. -3.71e+11. In the year 2008, what is the difference between the Exports of Kosovo and Exports of United Kingdom?
Offer a very short reply. -4.60e+11. In the year 2009, what is the difference between the Exports in Equatorial Guinea and Exports in Honduras?
Make the answer very short. 5.34e+12. In the year 2009, what is the difference between the Exports in Equatorial Guinea and Exports in Kosovo?
Ensure brevity in your answer.  5.41e+12. In the year 2009, what is the difference between the Exports of Equatorial Guinea and Exports of United Kingdom?
Provide a short and direct response. 4.99e+12. In the year 2009, what is the difference between the Exports of Honduras and Exports of Kosovo?
Provide a succinct answer. 7.47e+1. In the year 2009, what is the difference between the Exports of Honduras and Exports of United Kingdom?
Keep it short and to the point. -3.45e+11. In the year 2009, what is the difference between the Exports in Kosovo and Exports in United Kingdom?
Give a very brief answer. -4.19e+11. In the year 2010, what is the difference between the Exports of Equatorial Guinea and Exports of Honduras?
Your response must be concise. 5.02e+12. In the year 2010, what is the difference between the Exports in Equatorial Guinea and Exports in Kosovo?
Your response must be concise. 5.11e+12. In the year 2010, what is the difference between the Exports in Equatorial Guinea and Exports in United Kingdom?
Ensure brevity in your answer.  4.67e+12. In the year 2010, what is the difference between the Exports of Honduras and Exports of Kosovo?
Your answer should be very brief. 8.64e+1. In the year 2010, what is the difference between the Exports in Honduras and Exports in United Kingdom?
Keep it short and to the point. -3.57e+11. In the year 2010, what is the difference between the Exports of Kosovo and Exports of United Kingdom?
Offer a very short reply. -4.44e+11. In the year 2011, what is the difference between the Exports of Equatorial Guinea and Exports of Honduras?
Offer a terse response. 5.11e+12. In the year 2011, what is the difference between the Exports in Equatorial Guinea and Exports in Kosovo?
Provide a short and direct response. 5.20e+12. In the year 2011, what is the difference between the Exports in Equatorial Guinea and Exports in United Kingdom?
Your answer should be compact. 4.73e+12. In the year 2011, what is the difference between the Exports in Honduras and Exports in Kosovo?
Provide a short and direct response. 9.37e+1. In the year 2011, what is the difference between the Exports of Honduras and Exports of United Kingdom?
Provide a short and direct response. -3.76e+11. In the year 2011, what is the difference between the Exports of Kosovo and Exports of United Kingdom?
Keep it short and to the point. -4.70e+11. In the year 2012, what is the difference between the Exports of Equatorial Guinea and Exports of Honduras?
Make the answer very short. 5.48e+12. In the year 2012, what is the difference between the Exports of Equatorial Guinea and Exports of Kosovo?
Offer a terse response. 5.58e+12. In the year 2012, what is the difference between the Exports of Equatorial Guinea and Exports of United Kingdom?
Keep it short and to the point. 5.11e+12. In the year 2012, what is the difference between the Exports in Honduras and Exports in Kosovo?
Give a very brief answer. 1.03e+11. In the year 2012, what is the difference between the Exports in Honduras and Exports in United Kingdom?
Provide a succinct answer. -3.70e+11. In the year 2012, what is the difference between the Exports in Kosovo and Exports in United Kingdom?
Your answer should be compact. -4.73e+11. In the year 2013, what is the difference between the Exports of Equatorial Guinea and Exports of Honduras?
Offer a terse response. 5.03e+12. In the year 2013, what is the difference between the Exports in Equatorial Guinea and Exports in Kosovo?
Offer a terse response. 5.13e+12. In the year 2013, what is the difference between the Exports of Equatorial Guinea and Exports of United Kingdom?
Your answer should be very brief. 4.65e+12. In the year 2013, what is the difference between the Exports of Honduras and Exports of Kosovo?
Your response must be concise. 1.02e+11. In the year 2013, what is the difference between the Exports in Honduras and Exports in United Kingdom?
Provide a succinct answer. -3.77e+11. In the year 2013, what is the difference between the Exports in Kosovo and Exports in United Kingdom?
Your response must be concise. -4.79e+11. In the year 2014, what is the difference between the Exports of Equatorial Guinea and Exports of Honduras?
Offer a terse response. 5.08e+12. In the year 2014, what is the difference between the Exports of Equatorial Guinea and Exports of Kosovo?
Give a very brief answer. 5.19e+12. In the year 2014, what is the difference between the Exports in Equatorial Guinea and Exports in United Kingdom?
Your answer should be very brief. 4.70e+12. In the year 2014, what is the difference between the Exports of Honduras and Exports of Kosovo?
Ensure brevity in your answer.  1.03e+11. In the year 2014, what is the difference between the Exports of Honduras and Exports of United Kingdom?
Ensure brevity in your answer.  -3.84e+11. In the year 2014, what is the difference between the Exports of Kosovo and Exports of United Kingdom?
Your answer should be very brief. -4.87e+11. What is the ratio of the Exports in Equatorial Guinea in 2007 to that in 2008?
Make the answer very short. 1.06. What is the ratio of the Exports in Honduras in 2007 to that in 2008?
Make the answer very short. 0.99. What is the ratio of the Exports in Kosovo in 2007 to that in 2008?
Offer a very short reply. 1. What is the ratio of the Exports in United Kingdom in 2007 to that in 2008?
Ensure brevity in your answer.  0.99. What is the ratio of the Exports of Equatorial Guinea in 2007 to that in 2009?
Give a very brief answer. 1. What is the ratio of the Exports in Honduras in 2007 to that in 2009?
Keep it short and to the point. 1.18. What is the ratio of the Exports of Kosovo in 2007 to that in 2009?
Provide a short and direct response. 0.89. What is the ratio of the Exports of United Kingdom in 2007 to that in 2009?
Your answer should be compact. 1.08. What is the ratio of the Exports in Equatorial Guinea in 2007 to that in 2010?
Your answer should be very brief. 1.06. What is the ratio of the Exports of Kosovo in 2007 to that in 2010?
Provide a succinct answer. 0.79. What is the ratio of the Exports of United Kingdom in 2007 to that in 2010?
Offer a very short reply. 1.02. What is the ratio of the Exports of Equatorial Guinea in 2007 to that in 2011?
Provide a succinct answer. 1.04. What is the ratio of the Exports of Honduras in 2007 to that in 2011?
Your answer should be compact. 0.94. What is the ratio of the Exports in Kosovo in 2007 to that in 2011?
Ensure brevity in your answer.  0.76. What is the ratio of the Exports in Equatorial Guinea in 2007 to that in 2012?
Provide a short and direct response. 0.97. What is the ratio of the Exports in Honduras in 2007 to that in 2012?
Make the answer very short. 0.86. What is the ratio of the Exports of Kosovo in 2007 to that in 2012?
Your answer should be compact. 0.76. What is the ratio of the Exports in United Kingdom in 2007 to that in 2012?
Make the answer very short. 0.96. What is the ratio of the Exports of Equatorial Guinea in 2007 to that in 2013?
Make the answer very short. 1.06. What is the ratio of the Exports of Honduras in 2007 to that in 2013?
Your answer should be compact. 0.87. What is the ratio of the Exports of Kosovo in 2007 to that in 2013?
Provide a succinct answer. 0.74. What is the ratio of the Exports in United Kingdom in 2007 to that in 2013?
Make the answer very short. 0.95. What is the ratio of the Exports in Equatorial Guinea in 2007 to that in 2014?
Your response must be concise. 1.05. What is the ratio of the Exports in Honduras in 2007 to that in 2014?
Keep it short and to the point. 0.85. What is the ratio of the Exports in Kosovo in 2007 to that in 2014?
Provide a short and direct response. 0.63. What is the ratio of the Exports of United Kingdom in 2007 to that in 2014?
Provide a succinct answer. 0.93. What is the ratio of the Exports in Equatorial Guinea in 2008 to that in 2009?
Give a very brief answer. 0.95. What is the ratio of the Exports in Honduras in 2008 to that in 2009?
Make the answer very short. 1.19. What is the ratio of the Exports in Kosovo in 2008 to that in 2009?
Your response must be concise. 0.89. What is the ratio of the Exports in United Kingdom in 2008 to that in 2009?
Your answer should be very brief. 1.1. What is the ratio of the Exports of Equatorial Guinea in 2008 to that in 2010?
Your answer should be compact. 1. What is the ratio of the Exports in Honduras in 2008 to that in 2010?
Keep it short and to the point. 1.03. What is the ratio of the Exports of Kosovo in 2008 to that in 2010?
Your answer should be compact. 0.79. What is the ratio of the Exports in United Kingdom in 2008 to that in 2010?
Ensure brevity in your answer.  1.04. What is the ratio of the Exports in Equatorial Guinea in 2008 to that in 2011?
Offer a very short reply. 0.98. What is the ratio of the Exports in Honduras in 2008 to that in 2011?
Provide a succinct answer. 0.95. What is the ratio of the Exports of Kosovo in 2008 to that in 2011?
Keep it short and to the point. 0.76. What is the ratio of the Exports of United Kingdom in 2008 to that in 2011?
Keep it short and to the point. 0.98. What is the ratio of the Exports of Equatorial Guinea in 2008 to that in 2012?
Make the answer very short. 0.92. What is the ratio of the Exports of Honduras in 2008 to that in 2012?
Provide a short and direct response. 0.86. What is the ratio of the Exports of Kosovo in 2008 to that in 2012?
Provide a succinct answer. 0.76. What is the ratio of the Exports in United Kingdom in 2008 to that in 2012?
Keep it short and to the point. 0.97. What is the ratio of the Exports of Honduras in 2008 to that in 2013?
Provide a succinct answer. 0.87. What is the ratio of the Exports in Kosovo in 2008 to that in 2013?
Make the answer very short. 0.74. What is the ratio of the Exports in United Kingdom in 2008 to that in 2013?
Make the answer very short. 0.96. What is the ratio of the Exports of Equatorial Guinea in 2008 to that in 2014?
Offer a very short reply. 0.99. What is the ratio of the Exports of Honduras in 2008 to that in 2014?
Make the answer very short. 0.86. What is the ratio of the Exports in Kosovo in 2008 to that in 2014?
Your answer should be compact. 0.63. What is the ratio of the Exports in United Kingdom in 2008 to that in 2014?
Provide a short and direct response. 0.94. What is the ratio of the Exports in Equatorial Guinea in 2009 to that in 2010?
Give a very brief answer. 1.06. What is the ratio of the Exports in Honduras in 2009 to that in 2010?
Provide a succinct answer. 0.86. What is the ratio of the Exports of United Kingdom in 2009 to that in 2010?
Provide a succinct answer. 0.95. What is the ratio of the Exports in Equatorial Guinea in 2009 to that in 2011?
Your response must be concise. 1.04. What is the ratio of the Exports in Honduras in 2009 to that in 2011?
Your response must be concise. 0.8. What is the ratio of the Exports of Kosovo in 2009 to that in 2011?
Provide a short and direct response. 0.86. What is the ratio of the Exports of United Kingdom in 2009 to that in 2011?
Make the answer very short. 0.89. What is the ratio of the Exports of Equatorial Guinea in 2009 to that in 2012?
Make the answer very short. 0.97. What is the ratio of the Exports of Honduras in 2009 to that in 2012?
Provide a short and direct response. 0.73. What is the ratio of the Exports of United Kingdom in 2009 to that in 2012?
Offer a terse response. 0.89. What is the ratio of the Exports in Equatorial Guinea in 2009 to that in 2013?
Make the answer very short. 1.05. What is the ratio of the Exports in Honduras in 2009 to that in 2013?
Your answer should be compact. 0.74. What is the ratio of the Exports in Kosovo in 2009 to that in 2013?
Keep it short and to the point. 0.83. What is the ratio of the Exports in United Kingdom in 2009 to that in 2013?
Keep it short and to the point. 0.88. What is the ratio of the Exports of Equatorial Guinea in 2009 to that in 2014?
Provide a short and direct response. 1.04. What is the ratio of the Exports in Honduras in 2009 to that in 2014?
Provide a succinct answer. 0.72. What is the ratio of the Exports of Kosovo in 2009 to that in 2014?
Your answer should be compact. 0.71. What is the ratio of the Exports in United Kingdom in 2009 to that in 2014?
Ensure brevity in your answer.  0.86. What is the ratio of the Exports in Equatorial Guinea in 2010 to that in 2011?
Provide a succinct answer. 0.98. What is the ratio of the Exports of Honduras in 2010 to that in 2011?
Keep it short and to the point. 0.92. What is the ratio of the Exports in Kosovo in 2010 to that in 2011?
Offer a very short reply. 0.96. What is the ratio of the Exports in United Kingdom in 2010 to that in 2011?
Provide a short and direct response. 0.94. What is the ratio of the Exports of Equatorial Guinea in 2010 to that in 2012?
Offer a very short reply. 0.92. What is the ratio of the Exports in Honduras in 2010 to that in 2012?
Keep it short and to the point. 0.84. What is the ratio of the Exports in Kosovo in 2010 to that in 2012?
Your answer should be compact. 0.96. What is the ratio of the Exports in United Kingdom in 2010 to that in 2012?
Make the answer very short. 0.94. What is the ratio of the Exports of Equatorial Guinea in 2010 to that in 2013?
Provide a short and direct response. 1. What is the ratio of the Exports of Honduras in 2010 to that in 2013?
Offer a terse response. 0.85. What is the ratio of the Exports of Kosovo in 2010 to that in 2013?
Your answer should be very brief. 0.93. What is the ratio of the Exports in United Kingdom in 2010 to that in 2013?
Your response must be concise. 0.93. What is the ratio of the Exports in Equatorial Guinea in 2010 to that in 2014?
Ensure brevity in your answer.  0.98. What is the ratio of the Exports in Honduras in 2010 to that in 2014?
Provide a short and direct response. 0.84. What is the ratio of the Exports of Kosovo in 2010 to that in 2014?
Your response must be concise. 0.8. What is the ratio of the Exports in United Kingdom in 2010 to that in 2014?
Ensure brevity in your answer.  0.91. What is the ratio of the Exports of Equatorial Guinea in 2011 to that in 2012?
Your response must be concise. 0.93. What is the ratio of the Exports in Honduras in 2011 to that in 2012?
Offer a terse response. 0.91. What is the ratio of the Exports in United Kingdom in 2011 to that in 2012?
Your answer should be compact. 0.99. What is the ratio of the Exports of Equatorial Guinea in 2011 to that in 2013?
Provide a short and direct response. 1.01. What is the ratio of the Exports of Honduras in 2011 to that in 2013?
Offer a very short reply. 0.92. What is the ratio of the Exports of Kosovo in 2011 to that in 2013?
Your answer should be compact. 0.97. What is the ratio of the Exports in United Kingdom in 2011 to that in 2013?
Provide a succinct answer. 0.98. What is the ratio of the Exports of Honduras in 2011 to that in 2014?
Ensure brevity in your answer.  0.91. What is the ratio of the Exports of Kosovo in 2011 to that in 2014?
Your answer should be very brief. 0.83. What is the ratio of the Exports of United Kingdom in 2011 to that in 2014?
Provide a short and direct response. 0.96. What is the ratio of the Exports in Equatorial Guinea in 2012 to that in 2013?
Your answer should be compact. 1.09. What is the ratio of the Exports of Kosovo in 2012 to that in 2013?
Keep it short and to the point. 0.98. What is the ratio of the Exports in United Kingdom in 2012 to that in 2013?
Make the answer very short. 0.99. What is the ratio of the Exports in Equatorial Guinea in 2012 to that in 2014?
Ensure brevity in your answer.  1.08. What is the ratio of the Exports of Kosovo in 2012 to that in 2014?
Offer a terse response. 0.83. What is the ratio of the Exports of United Kingdom in 2012 to that in 2014?
Give a very brief answer. 0.97. What is the ratio of the Exports in Equatorial Guinea in 2013 to that in 2014?
Give a very brief answer. 0.99. What is the ratio of the Exports of Honduras in 2013 to that in 2014?
Offer a terse response. 0.98. What is the ratio of the Exports in Kosovo in 2013 to that in 2014?
Provide a short and direct response. 0.85. What is the ratio of the Exports of United Kingdom in 2013 to that in 2014?
Your answer should be compact. 0.98. What is the difference between the highest and the second highest Exports of Equatorial Guinea?
Offer a very short reply. 1.57e+11. What is the difference between the highest and the second highest Exports of Honduras?
Provide a short and direct response. 2.79e+08. What is the difference between the highest and the second highest Exports in Kosovo?
Offer a terse response. 1.41e+08. What is the difference between the highest and the second highest Exports of United Kingdom?
Offer a very short reply. 8.71e+09. What is the difference between the highest and the lowest Exports in Equatorial Guinea?
Your answer should be very brief. 4.75e+11. What is the difference between the highest and the lowest Exports of Honduras?
Provide a succinct answer. 2.87e+1. What is the difference between the highest and the lowest Exports in Kosovo?
Ensure brevity in your answer.  3.57e+08. What is the difference between the highest and the lowest Exports in United Kingdom?
Provide a succinct answer. 6.81e+1. 